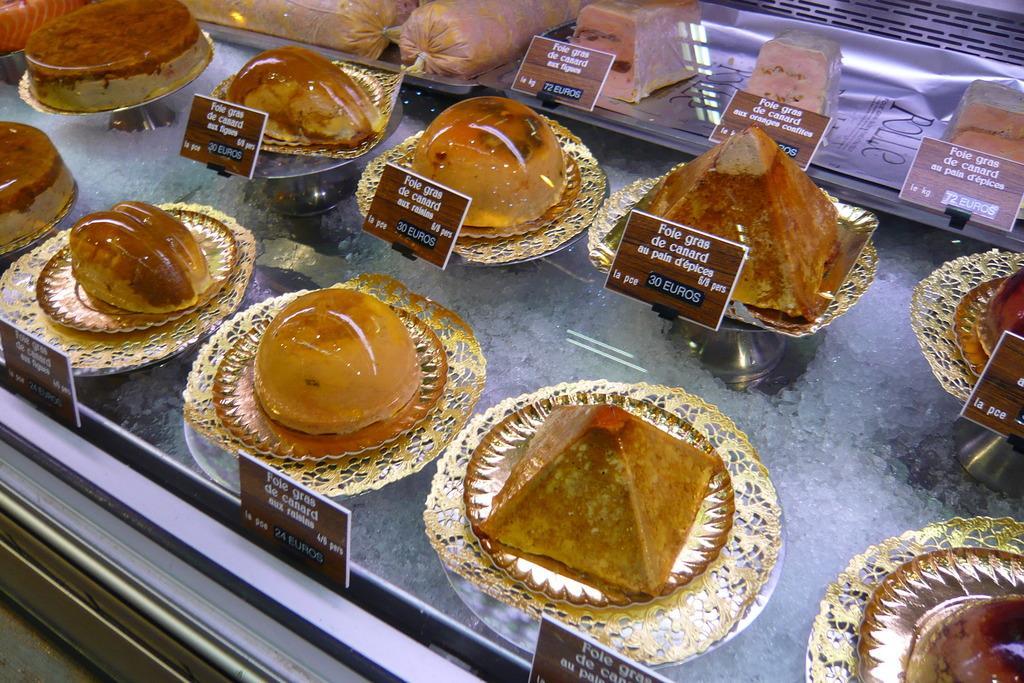How would you summarize this image in a sentence or two? In the center of the image we can see food items in plates. 